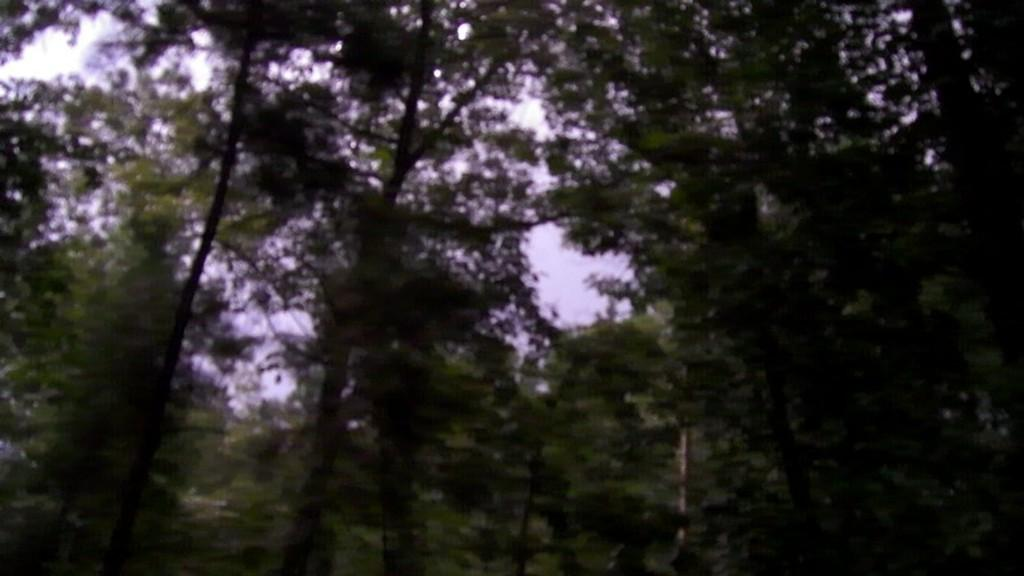What type of vegetation can be seen in the image? There are trees in the image. What type of screw can be seen holding the note to the tree in the image? There is no screw or note present in the image; it only features trees. 